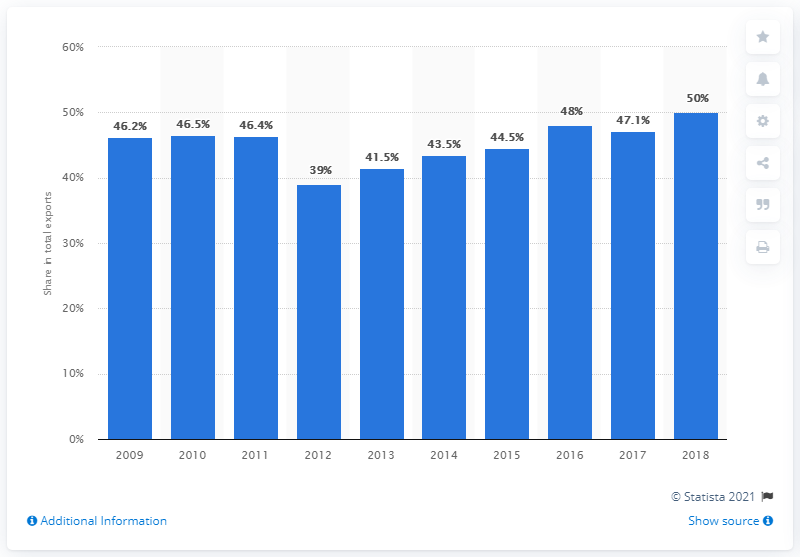Draw attention to some important aspects in this diagram. The share of Turkish exports to the EU decreased in 2012. 